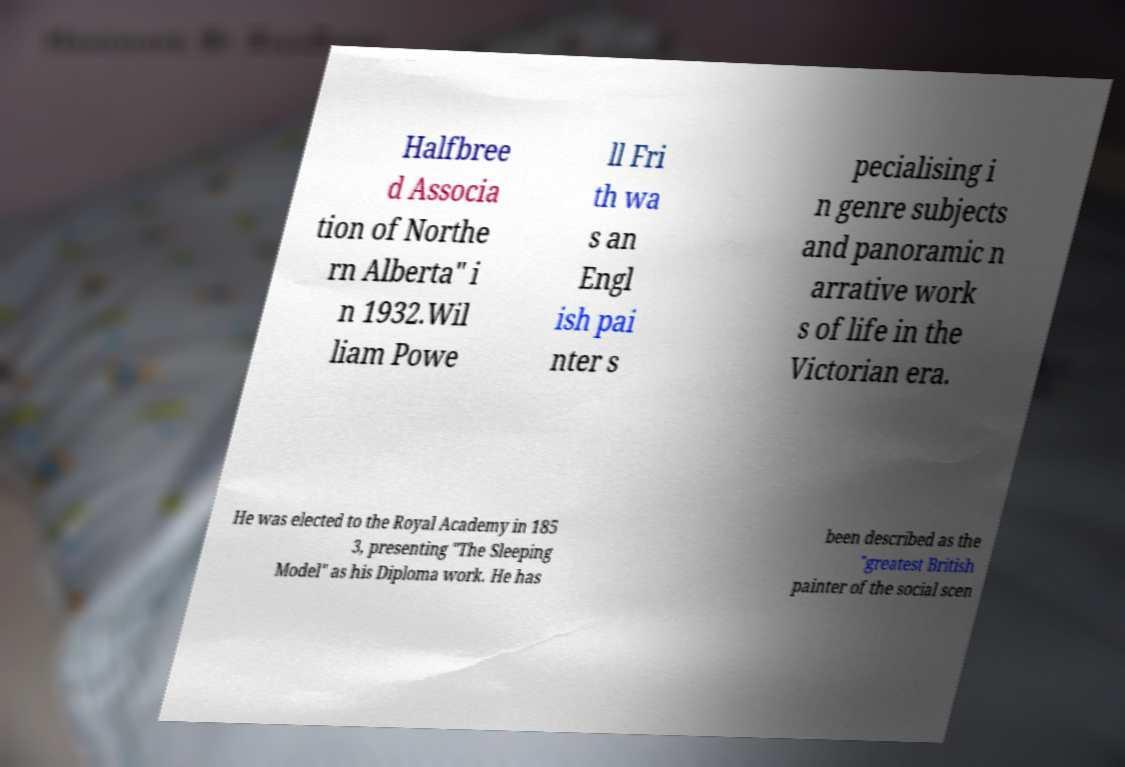Can you read and provide the text displayed in the image?This photo seems to have some interesting text. Can you extract and type it out for me? Halfbree d Associa tion of Northe rn Alberta" i n 1932.Wil liam Powe ll Fri th wa s an Engl ish pai nter s pecialising i n genre subjects and panoramic n arrative work s of life in the Victorian era. He was elected to the Royal Academy in 185 3, presenting "The Sleeping Model" as his Diploma work. He has been described as the "greatest British painter of the social scen 